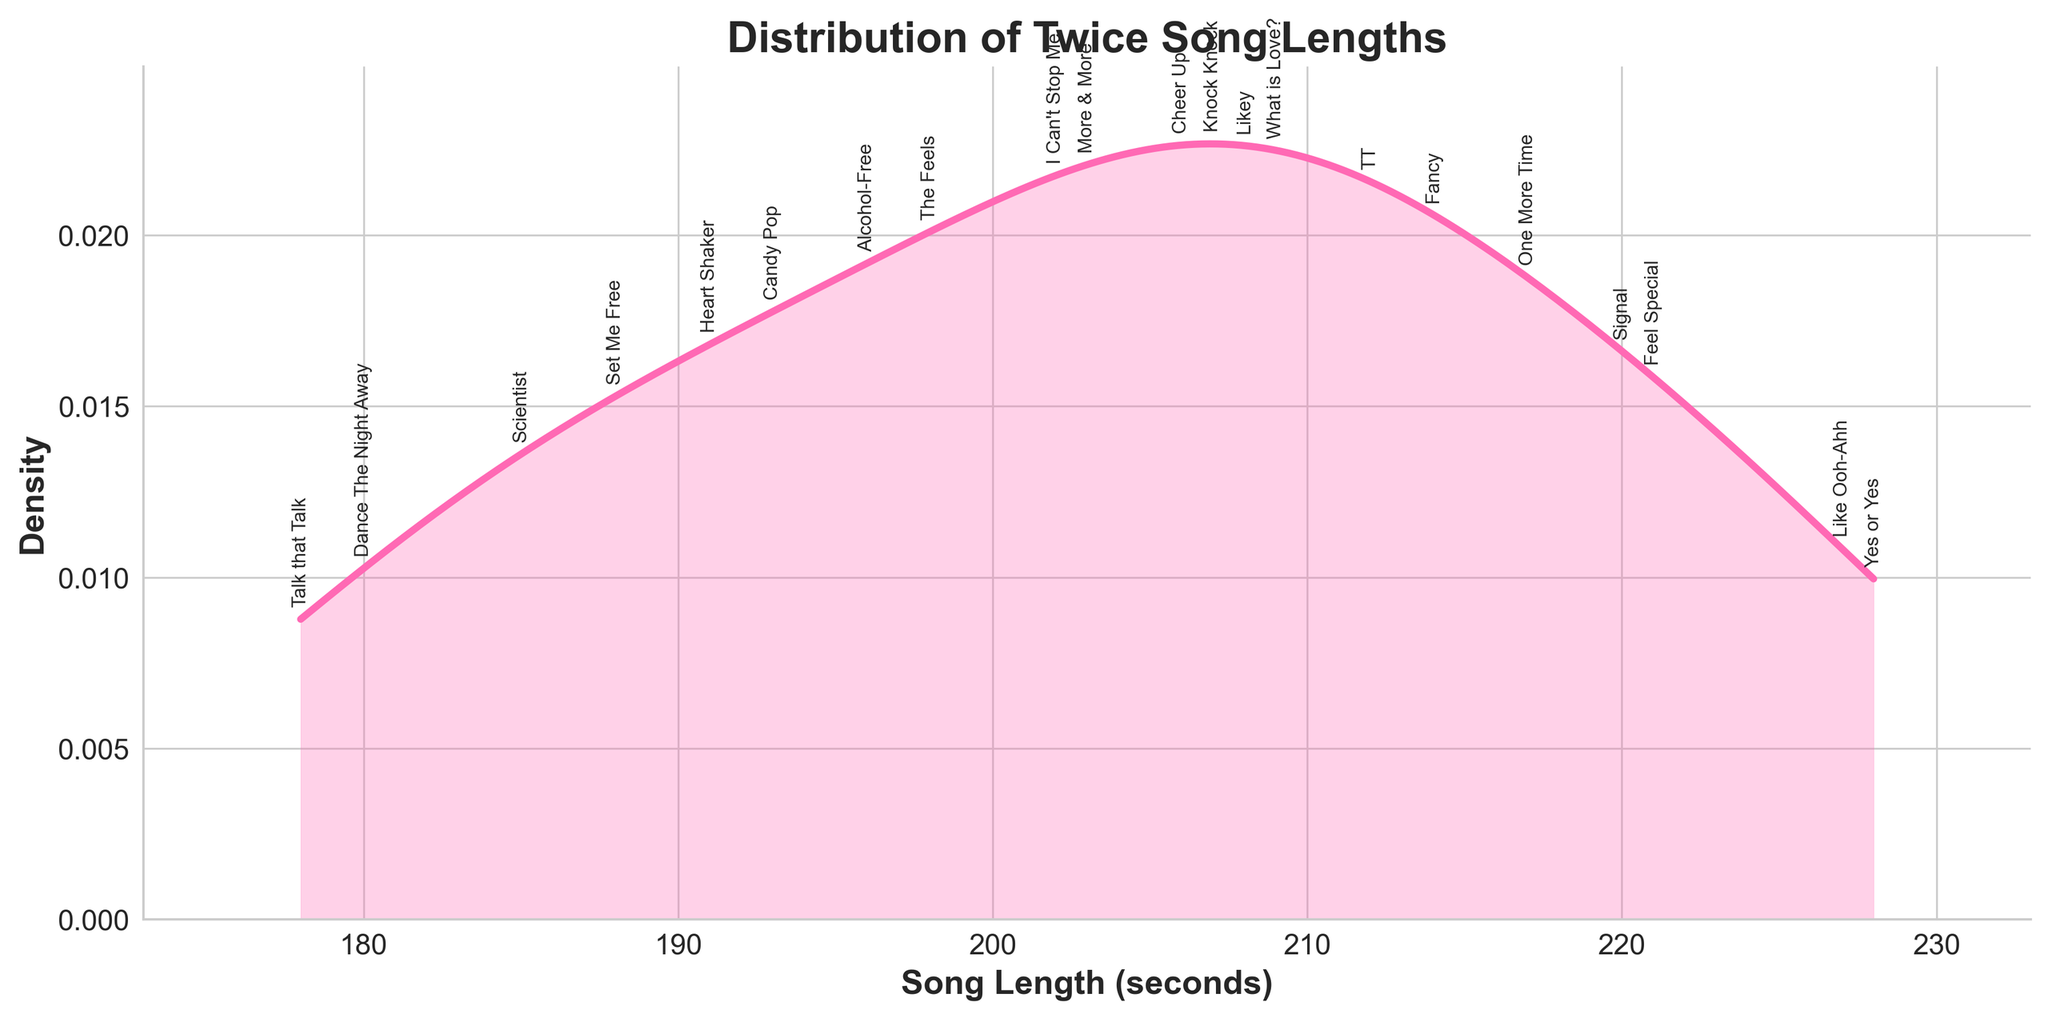what is the title of the plot? The title of the plot is usually found at the top of the figure. In this case, it reads "Distribution of Twice Song Lengths".
Answer: Distribution of Twice Song Lengths how many seconds long is the shortest song in the plot? Look at the x-axis and identify the point where the density starts, which represents the shortest song length. The shortest song is "Talk that Talk" which is 178 seconds long.
Answer: 178 seconds is the density of songs higher around 200 seconds or 220 seconds? Observe the density curve. Around 200 seconds, the curve is higher than around 220 seconds, indicating a higher density of songs.
Answer: 200 seconds what is the most common song length range? The peak of the density curve indicates the most common length range. The curve peaks around 190-210 seconds.
Answer: 190-210 seconds how does the song length of "Yes or Yes" compare to the peak of the density curve? Find "Yes or Yes" on the plot and compare its length (228 seconds) to the peak (around 200 seconds). "Yes or Yes" has a longer length compared to the peak.
Answer: Longer which song is the closest in length to "Feel Special"? Find the length of "Feel Special" (221 seconds) and identify other songs near this length. "Signal" at 220 seconds is the closest.
Answer: Signal how many songs have lengths between 180 and 200 seconds? Count the songs within the specified range. They are "Dance The Night Away", "Talk that Talk", "Set Me Free", "Alcohol-Free", "The Feels", and "Candy Pop". There are 6 songs.
Answer: 6 songs which song has the highest density according to the plot? The song at the peak of the density curve has the highest density. "Cheer Up" at 206 seconds is at the highest point.
Answer: Cheer Up how does the distribution of song lengths change from 180 to 220 seconds? Examine the shape of the curve from 180 to 220 seconds. The density increases around 190-210 seconds, then decreases as it moves towards 220 seconds.
Answer: Increases then decreases are there any songs longer than "Like Ooh-Ahh"? Check the plot for any points beyond the length of "Like Ooh-Ahh" (227 seconds). "Yes or Yes" at 228 seconds is longer.
Answer: Yes 